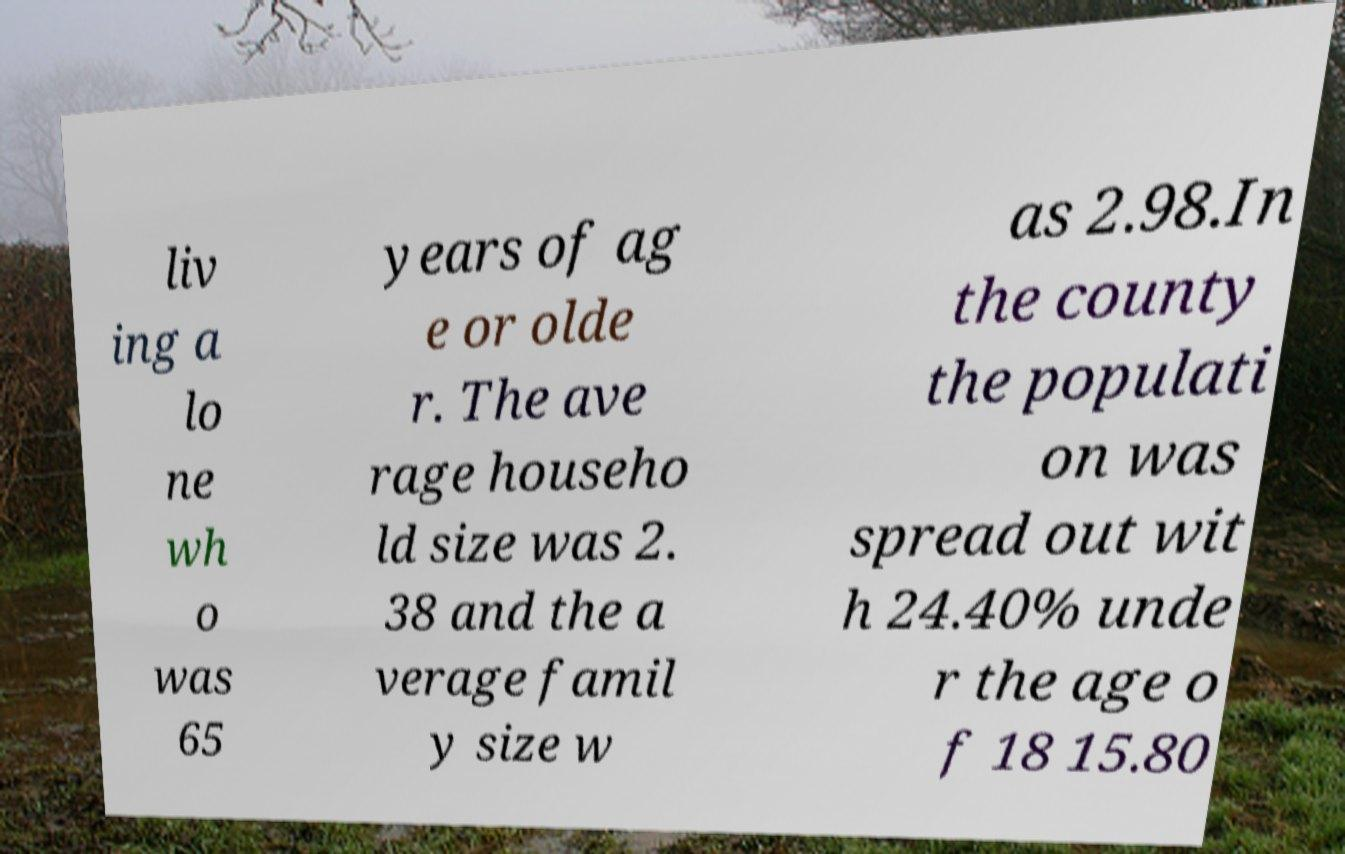What messages or text are displayed in this image? I need them in a readable, typed format. liv ing a lo ne wh o was 65 years of ag e or olde r. The ave rage househo ld size was 2. 38 and the a verage famil y size w as 2.98.In the county the populati on was spread out wit h 24.40% unde r the age o f 18 15.80 